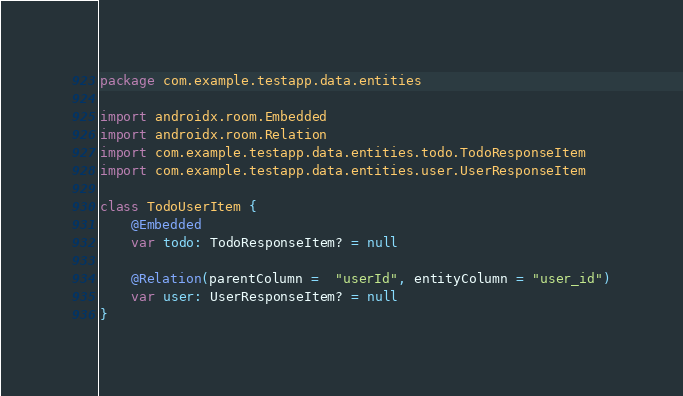Convert code to text. <code><loc_0><loc_0><loc_500><loc_500><_Kotlin_>package com.example.testapp.data.entities

import androidx.room.Embedded
import androidx.room.Relation
import com.example.testapp.data.entities.todo.TodoResponseItem
import com.example.testapp.data.entities.user.UserResponseItem

class TodoUserItem {
    @Embedded
    var todo: TodoResponseItem? = null

    @Relation(parentColumn =  "userId", entityColumn = "user_id")
    var user: UserResponseItem? = null
}</code> 